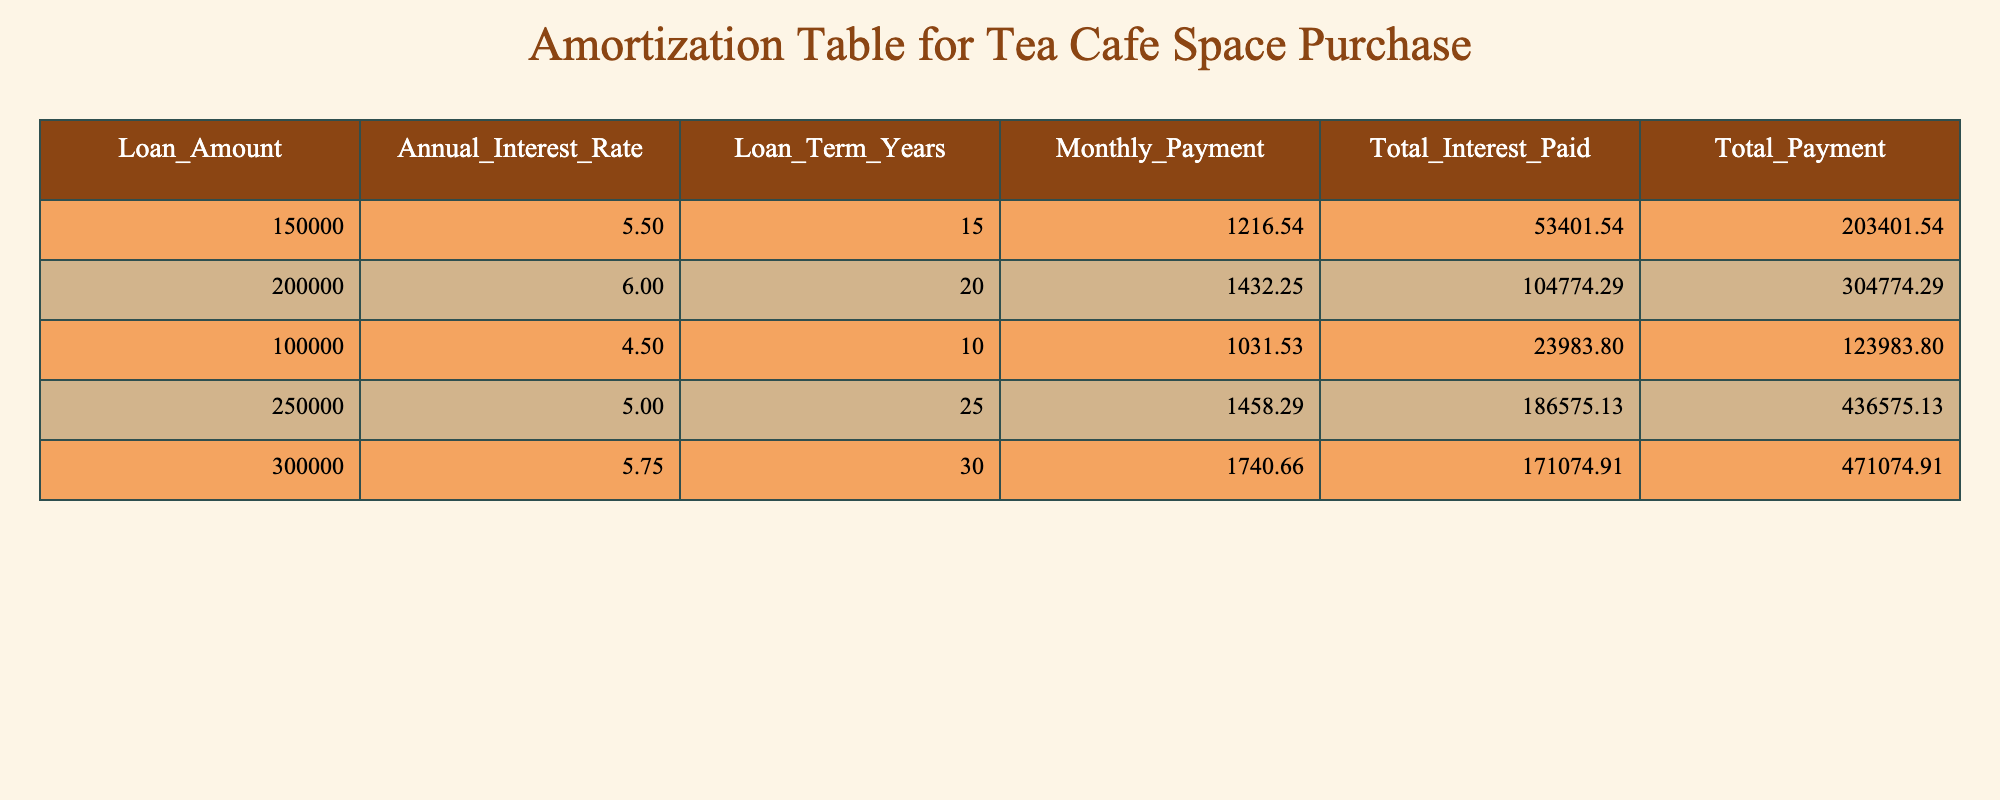What is the monthly payment for a loan of $300,000? From the table, we can see that the monthly payment for a loan amount of $300,000 is listed directly under the "Monthly Payment" column corresponding to this loan amount.
Answer: 1740.66 How much total interest will be paid for a loan of $200,000? By looking at the table, the total interest paid for the loan amount of $200,000 is displayed in the column labeled "Total Interest Paid". It shows the value directly.
Answer: 104774.29 Which loan has the highest total payment? To determine this, we need to look at the "Total Payment" column and compare the values for all loans listed. The loan amount of $250,000 has the largest total payment, which is 436575.13.
Answer: 436575.13 Is the total interest paid for a $100,000 loan greater than for a $150,000 loan? The total interest paid for the $100,000 loan is 23983.80 and for the $150,000 loan, it is 53401.54. Comparing these two values, 23983.80 is not greater than 53401.54, so the statement is false.
Answer: No What is the difference in monthly payments between the $250,000 loan and the $150,000 loan? The monthly payment for the $250,000 loan is 1458.29 and for the $150,000 loan, it is 1216.54. To find the difference, we subtract: 1458.29 - 1216.54 = 241.75.
Answer: 241.75 What is the average total interest paid across all loans listed? To calculate the average, we first sum up the total interest paid for all loans: 53401.54 + 104774.29 + 23983.80 + 186575.13 + 171074.91 = 534809.67. Then, we divide this total by the number of loans (5): 534809.67 / 5 = 106961.93.
Answer: 106961.93 Is it true that all loans listed have a higher monthly payment than $1,000? Checking the "Monthly Payment" column, we can see that all values (1216.54, 1432.25, 1031.53, 1458.29, 1740.66) exceed $1,000. Thus, this is true.
Answer: Yes Which loan has the lowest annual interest rate? By examining the "Annual Interest Rate" column, the loan amount of $100,000 has the lowest annual interest rate listed, which is 4.5%.
Answer: 4.5% 